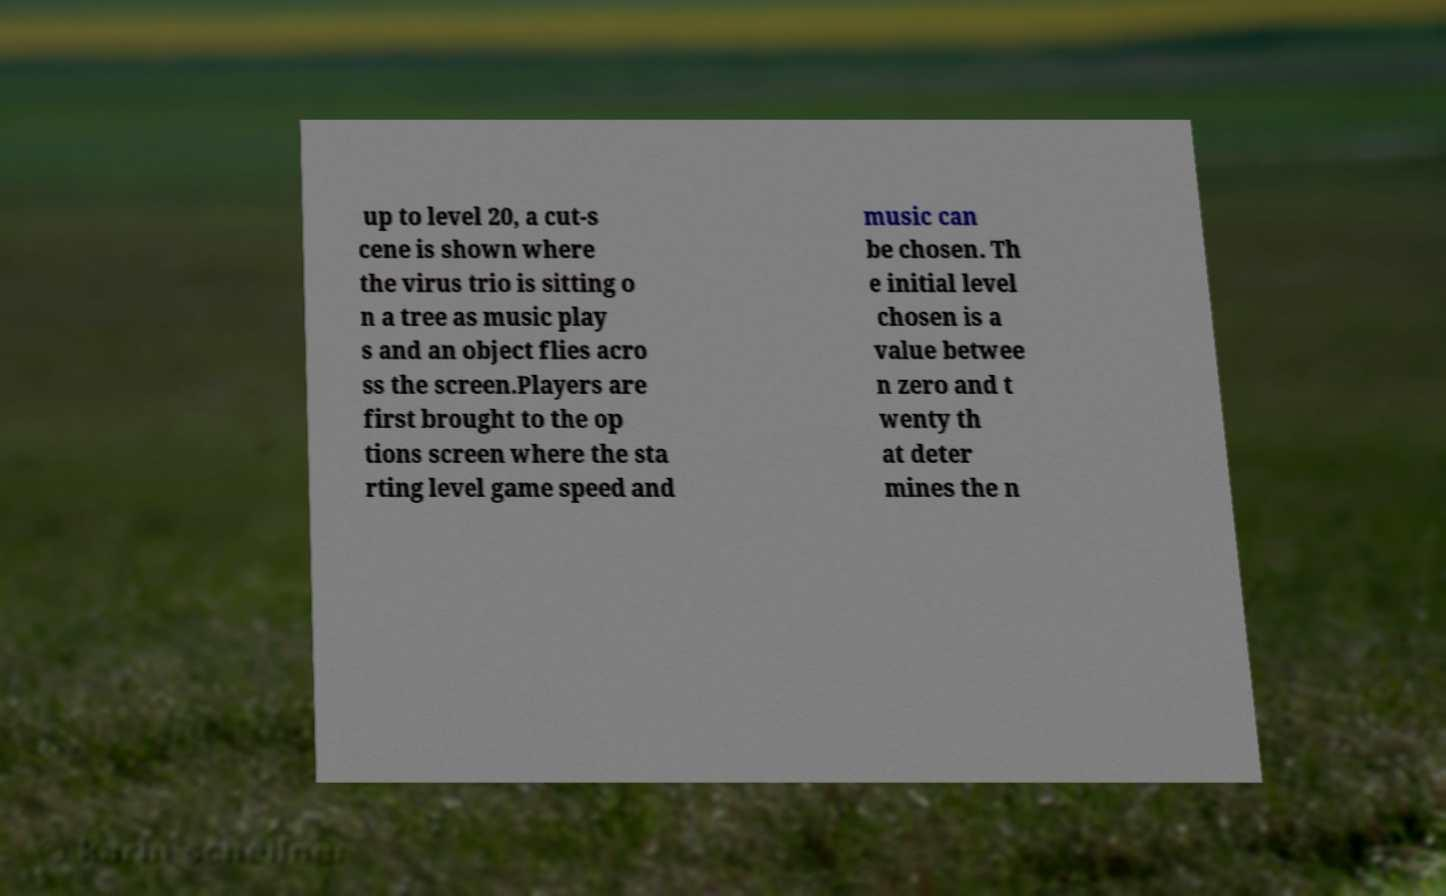Can you accurately transcribe the text from the provided image for me? up to level 20, a cut-s cene is shown where the virus trio is sitting o n a tree as music play s and an object flies acro ss the screen.Players are first brought to the op tions screen where the sta rting level game speed and music can be chosen. Th e initial level chosen is a value betwee n zero and t wenty th at deter mines the n 